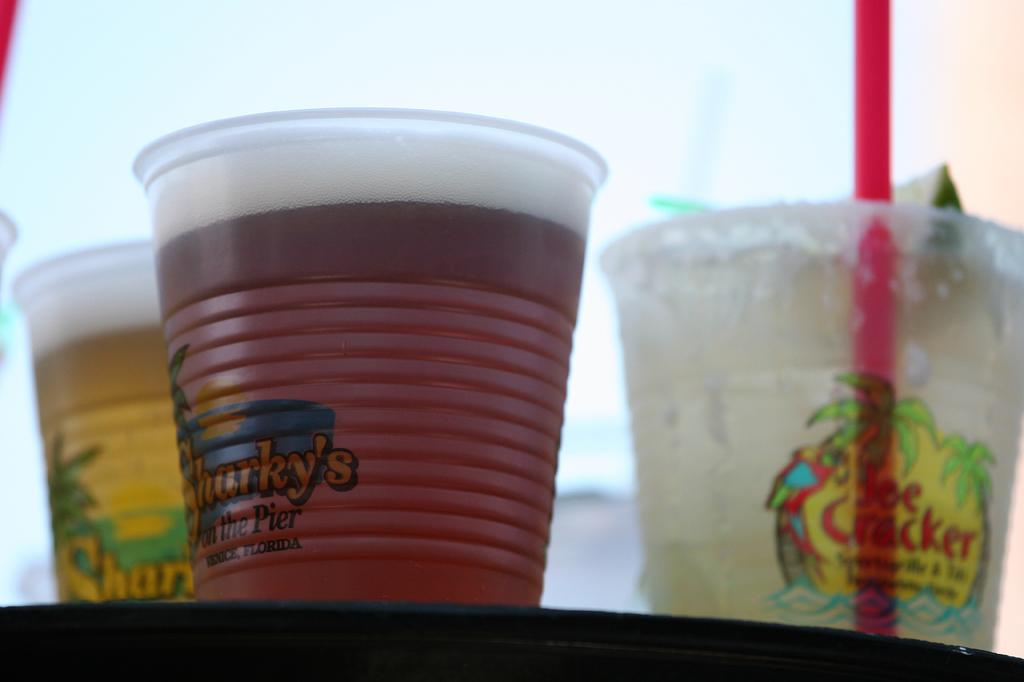What can be seen in the glasses in the image? There are drinks in the glasses in the image. How is one of the drinks being consumed? One glass has a straw in it, which suggests that the drink is being consumed by sucking through the straw. Where are the glasses placed in the image? The glasses are on a platform in the image. What rule is being enforced in the image regarding the appliance? There is no appliance present in the image, and therefore no rule regarding an appliance can be observed. 